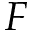<formula> <loc_0><loc_0><loc_500><loc_500>F</formula> 